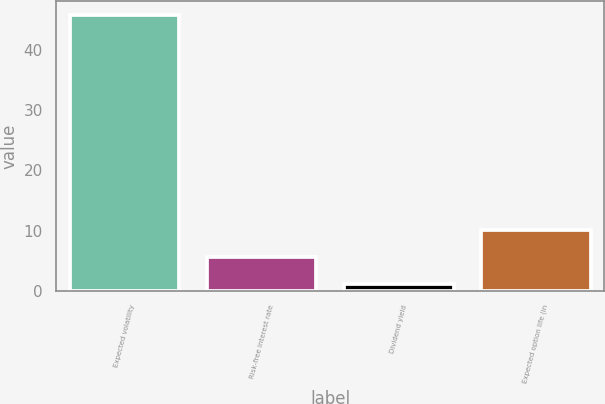Convert chart to OTSL. <chart><loc_0><loc_0><loc_500><loc_500><bar_chart><fcel>Expected volatility<fcel>Risk-free interest rate<fcel>Dividend yield<fcel>Expected option life (in<nl><fcel>45.75<fcel>5.62<fcel>1.16<fcel>10.08<nl></chart> 